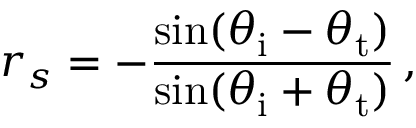<formula> <loc_0><loc_0><loc_500><loc_500>r _ { s } = - { \frac { \sin ( \theta _ { i } - \theta _ { t } ) } { \sin ( \theta _ { i } + \theta _ { t } ) } } \, ,</formula> 